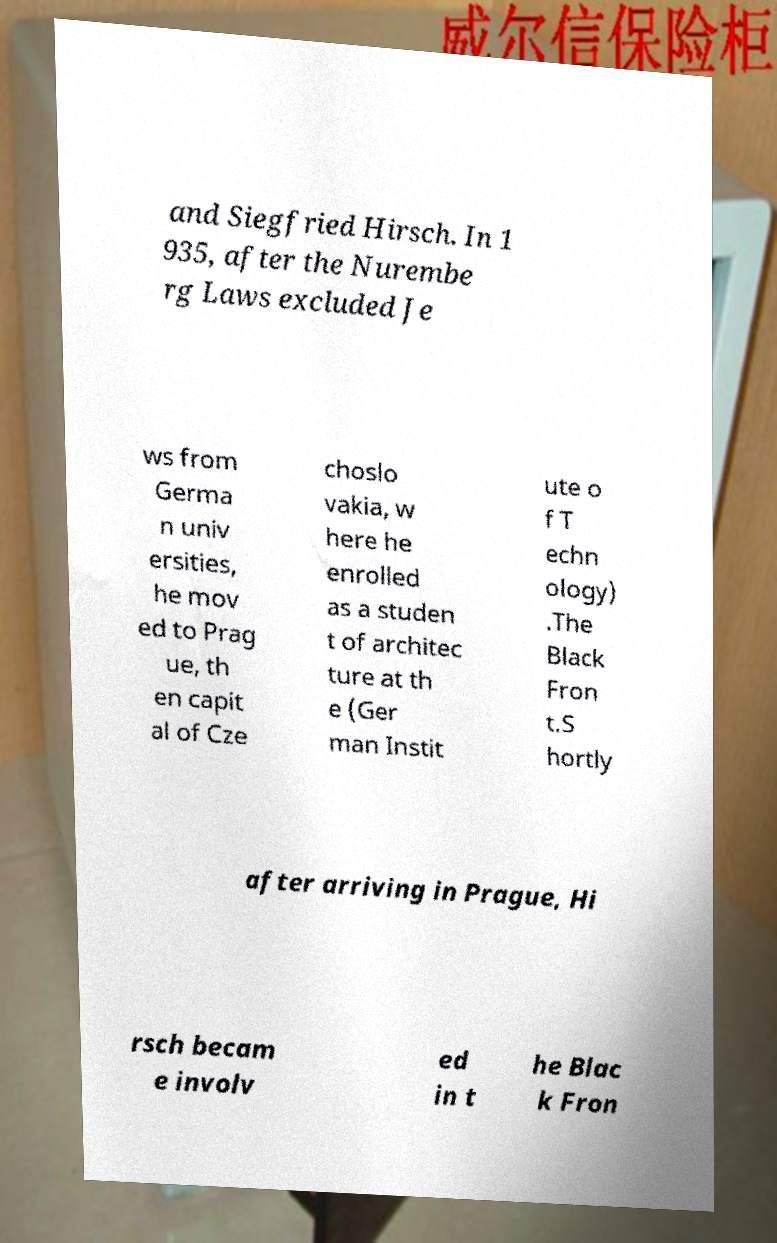What messages or text are displayed in this image? I need them in a readable, typed format. and Siegfried Hirsch. In 1 935, after the Nurembe rg Laws excluded Je ws from Germa n univ ersities, he mov ed to Prag ue, th en capit al of Cze choslo vakia, w here he enrolled as a studen t of architec ture at th e (Ger man Instit ute o f T echn ology) .The Black Fron t.S hortly after arriving in Prague, Hi rsch becam e involv ed in t he Blac k Fron 